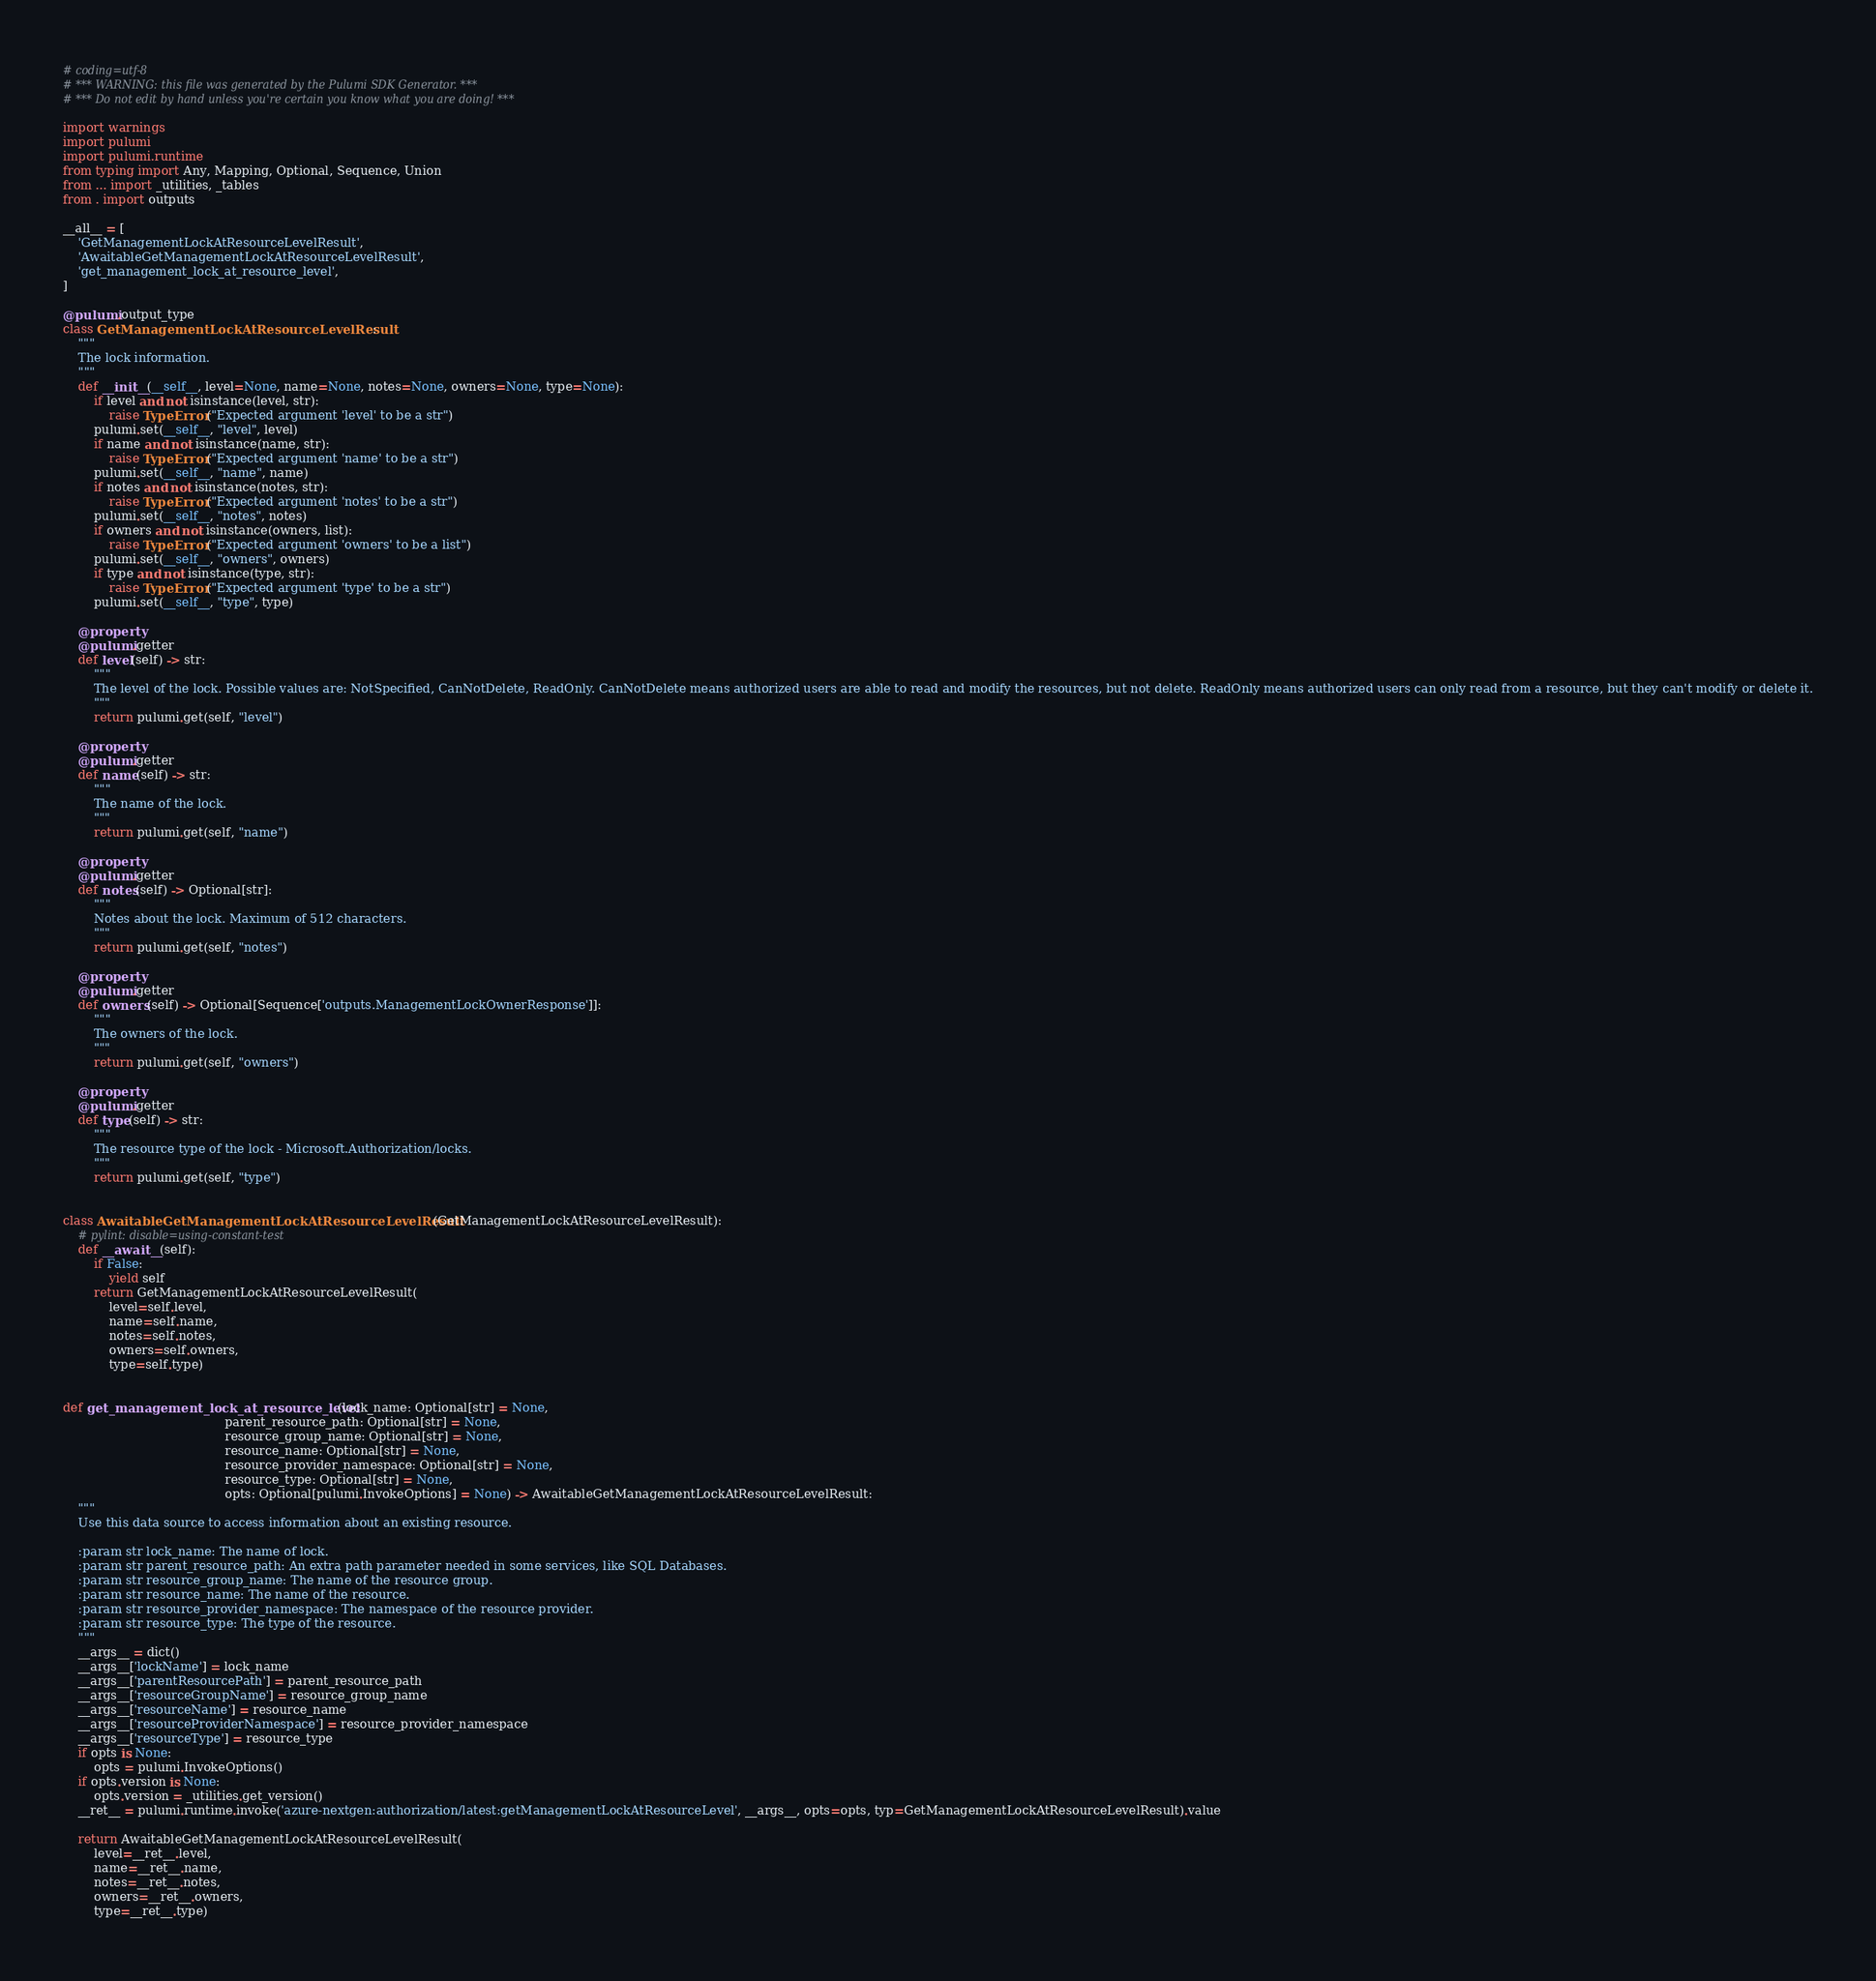Convert code to text. <code><loc_0><loc_0><loc_500><loc_500><_Python_># coding=utf-8
# *** WARNING: this file was generated by the Pulumi SDK Generator. ***
# *** Do not edit by hand unless you're certain you know what you are doing! ***

import warnings
import pulumi
import pulumi.runtime
from typing import Any, Mapping, Optional, Sequence, Union
from ... import _utilities, _tables
from . import outputs

__all__ = [
    'GetManagementLockAtResourceLevelResult',
    'AwaitableGetManagementLockAtResourceLevelResult',
    'get_management_lock_at_resource_level',
]

@pulumi.output_type
class GetManagementLockAtResourceLevelResult:
    """
    The lock information.
    """
    def __init__(__self__, level=None, name=None, notes=None, owners=None, type=None):
        if level and not isinstance(level, str):
            raise TypeError("Expected argument 'level' to be a str")
        pulumi.set(__self__, "level", level)
        if name and not isinstance(name, str):
            raise TypeError("Expected argument 'name' to be a str")
        pulumi.set(__self__, "name", name)
        if notes and not isinstance(notes, str):
            raise TypeError("Expected argument 'notes' to be a str")
        pulumi.set(__self__, "notes", notes)
        if owners and not isinstance(owners, list):
            raise TypeError("Expected argument 'owners' to be a list")
        pulumi.set(__self__, "owners", owners)
        if type and not isinstance(type, str):
            raise TypeError("Expected argument 'type' to be a str")
        pulumi.set(__self__, "type", type)

    @property
    @pulumi.getter
    def level(self) -> str:
        """
        The level of the lock. Possible values are: NotSpecified, CanNotDelete, ReadOnly. CanNotDelete means authorized users are able to read and modify the resources, but not delete. ReadOnly means authorized users can only read from a resource, but they can't modify or delete it.
        """
        return pulumi.get(self, "level")

    @property
    @pulumi.getter
    def name(self) -> str:
        """
        The name of the lock.
        """
        return pulumi.get(self, "name")

    @property
    @pulumi.getter
    def notes(self) -> Optional[str]:
        """
        Notes about the lock. Maximum of 512 characters.
        """
        return pulumi.get(self, "notes")

    @property
    @pulumi.getter
    def owners(self) -> Optional[Sequence['outputs.ManagementLockOwnerResponse']]:
        """
        The owners of the lock.
        """
        return pulumi.get(self, "owners")

    @property
    @pulumi.getter
    def type(self) -> str:
        """
        The resource type of the lock - Microsoft.Authorization/locks.
        """
        return pulumi.get(self, "type")


class AwaitableGetManagementLockAtResourceLevelResult(GetManagementLockAtResourceLevelResult):
    # pylint: disable=using-constant-test
    def __await__(self):
        if False:
            yield self
        return GetManagementLockAtResourceLevelResult(
            level=self.level,
            name=self.name,
            notes=self.notes,
            owners=self.owners,
            type=self.type)


def get_management_lock_at_resource_level(lock_name: Optional[str] = None,
                                          parent_resource_path: Optional[str] = None,
                                          resource_group_name: Optional[str] = None,
                                          resource_name: Optional[str] = None,
                                          resource_provider_namespace: Optional[str] = None,
                                          resource_type: Optional[str] = None,
                                          opts: Optional[pulumi.InvokeOptions] = None) -> AwaitableGetManagementLockAtResourceLevelResult:
    """
    Use this data source to access information about an existing resource.

    :param str lock_name: The name of lock.
    :param str parent_resource_path: An extra path parameter needed in some services, like SQL Databases.
    :param str resource_group_name: The name of the resource group. 
    :param str resource_name: The name of the resource.
    :param str resource_provider_namespace: The namespace of the resource provider.
    :param str resource_type: The type of the resource.
    """
    __args__ = dict()
    __args__['lockName'] = lock_name
    __args__['parentResourcePath'] = parent_resource_path
    __args__['resourceGroupName'] = resource_group_name
    __args__['resourceName'] = resource_name
    __args__['resourceProviderNamespace'] = resource_provider_namespace
    __args__['resourceType'] = resource_type
    if opts is None:
        opts = pulumi.InvokeOptions()
    if opts.version is None:
        opts.version = _utilities.get_version()
    __ret__ = pulumi.runtime.invoke('azure-nextgen:authorization/latest:getManagementLockAtResourceLevel', __args__, opts=opts, typ=GetManagementLockAtResourceLevelResult).value

    return AwaitableGetManagementLockAtResourceLevelResult(
        level=__ret__.level,
        name=__ret__.name,
        notes=__ret__.notes,
        owners=__ret__.owners,
        type=__ret__.type)
</code> 